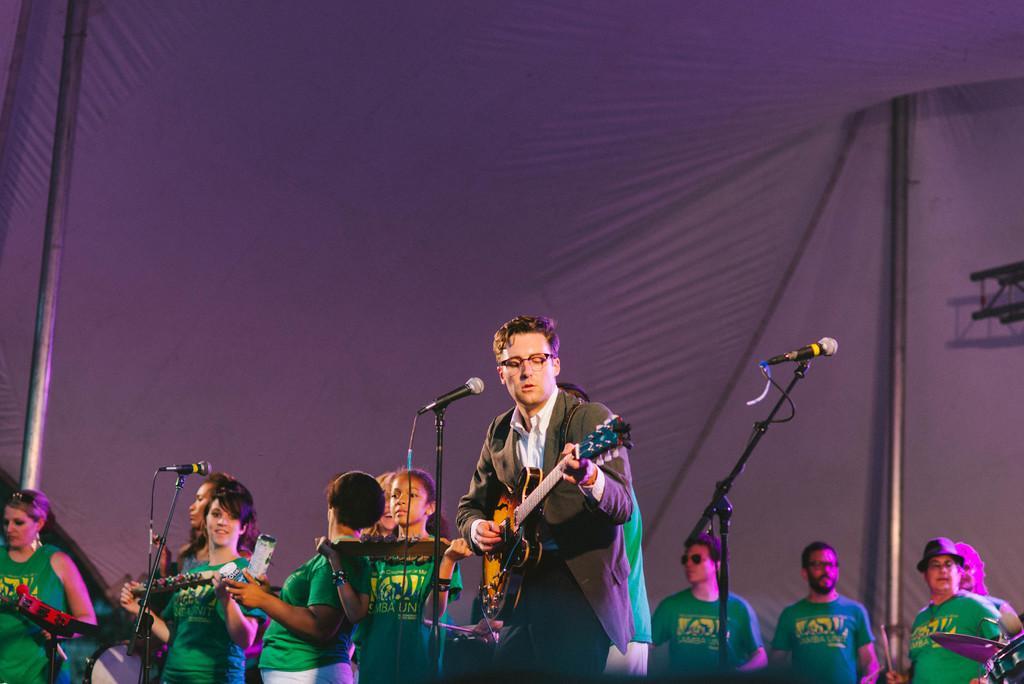How would you summarize this image in a sentence or two? In this picture we can see some persons are playing musical instruments. He is in suit and he has spectacles. These are the mikes and there is a pole. 